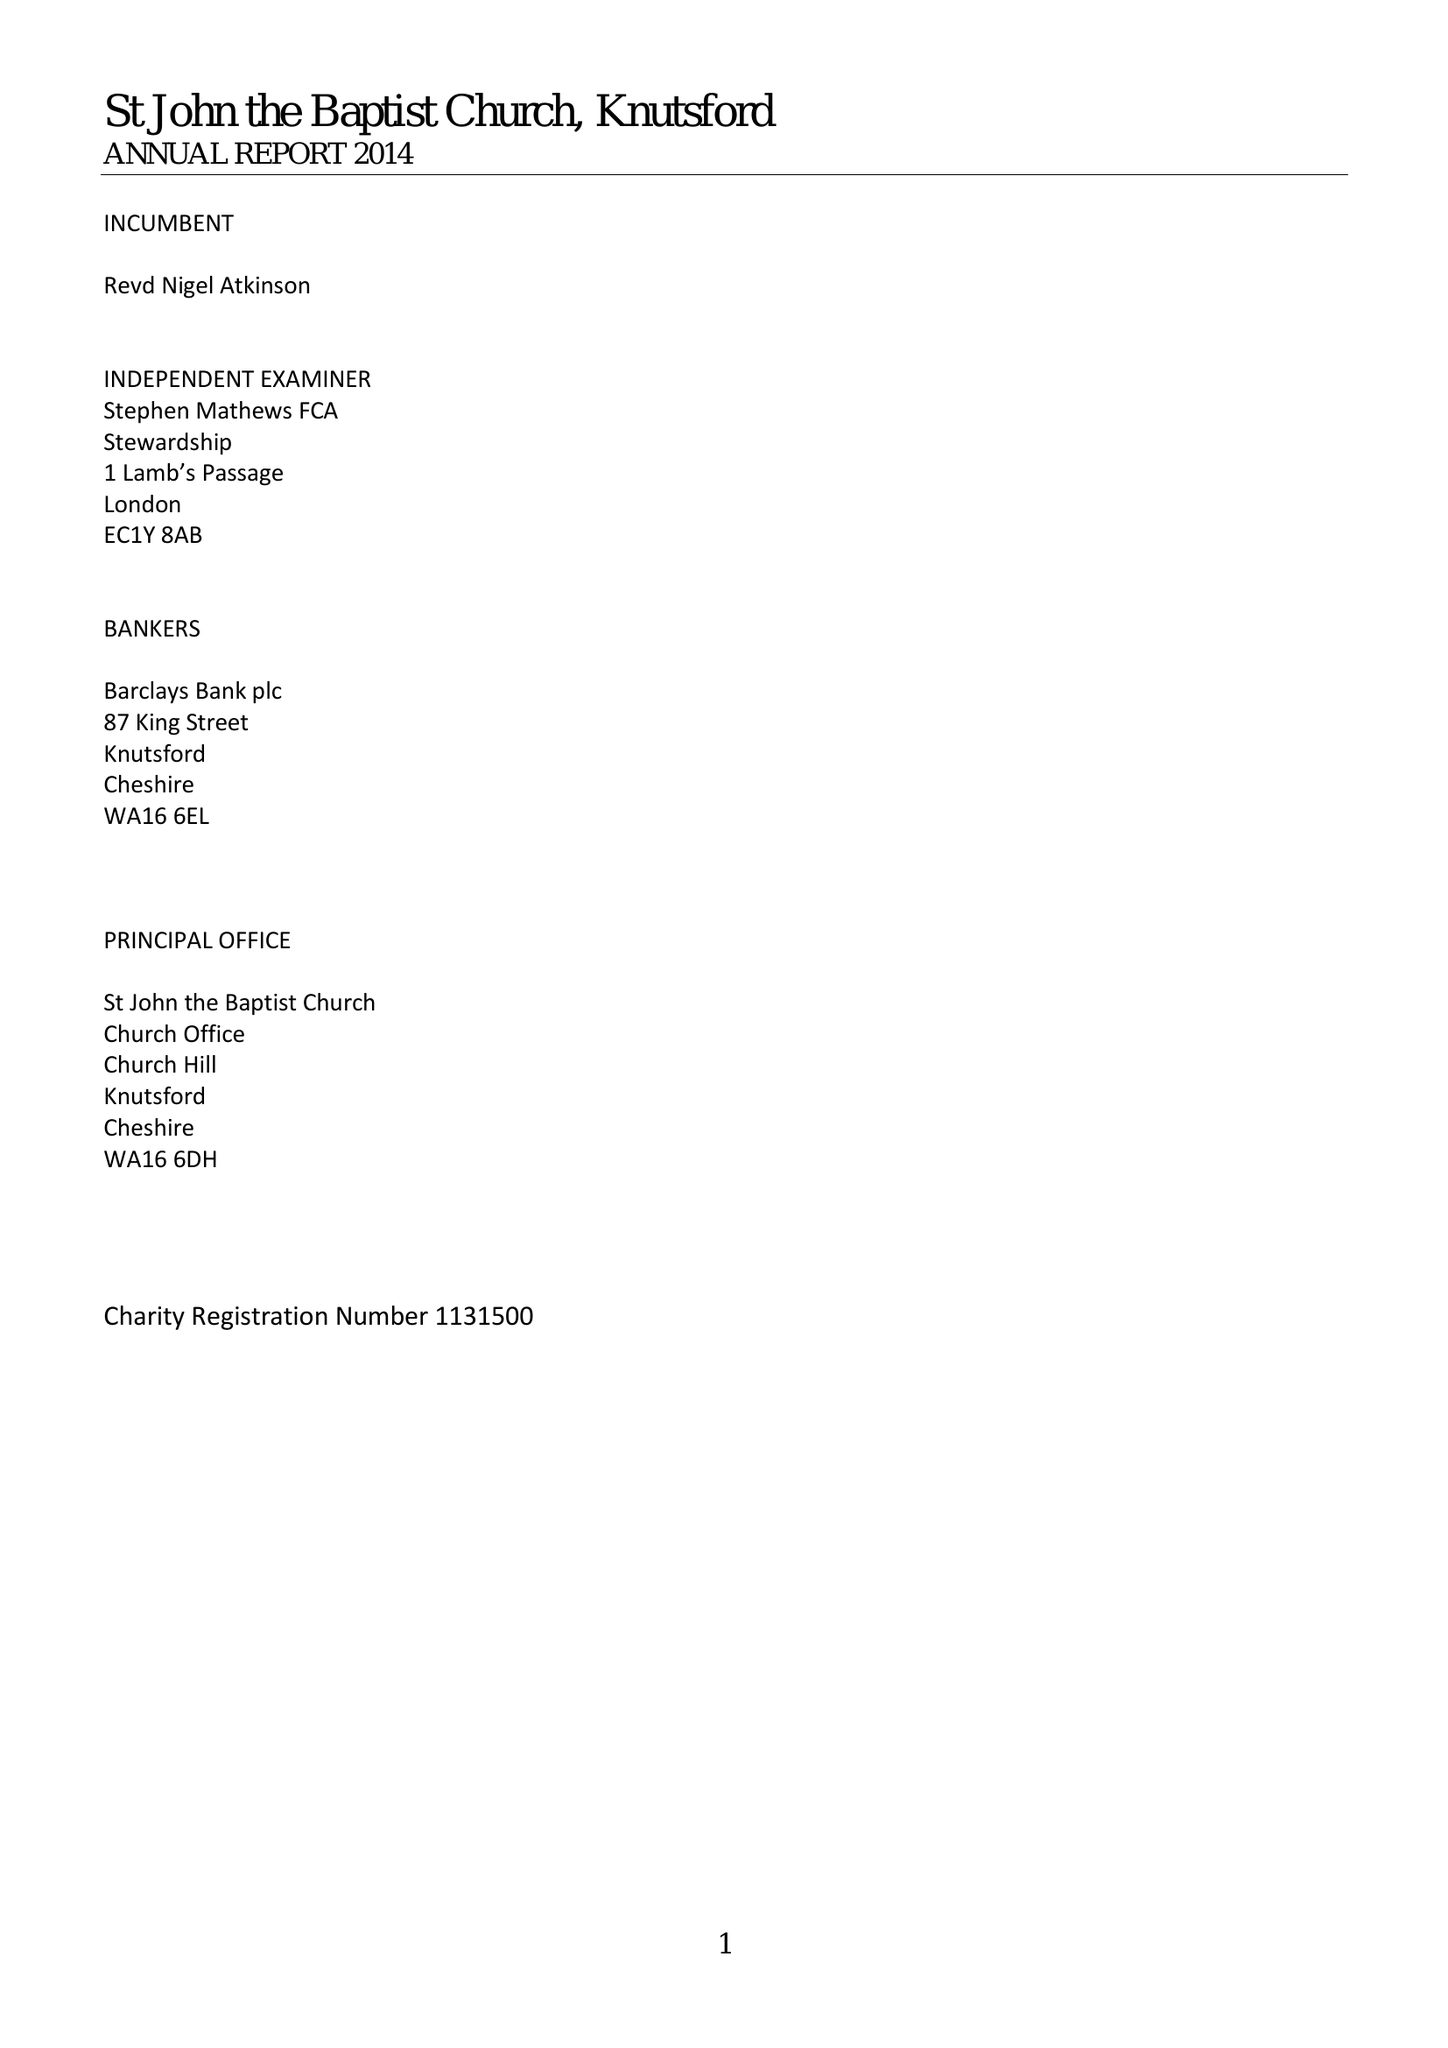What is the value for the address__post_town?
Answer the question using a single word or phrase. KNUTSFORD 